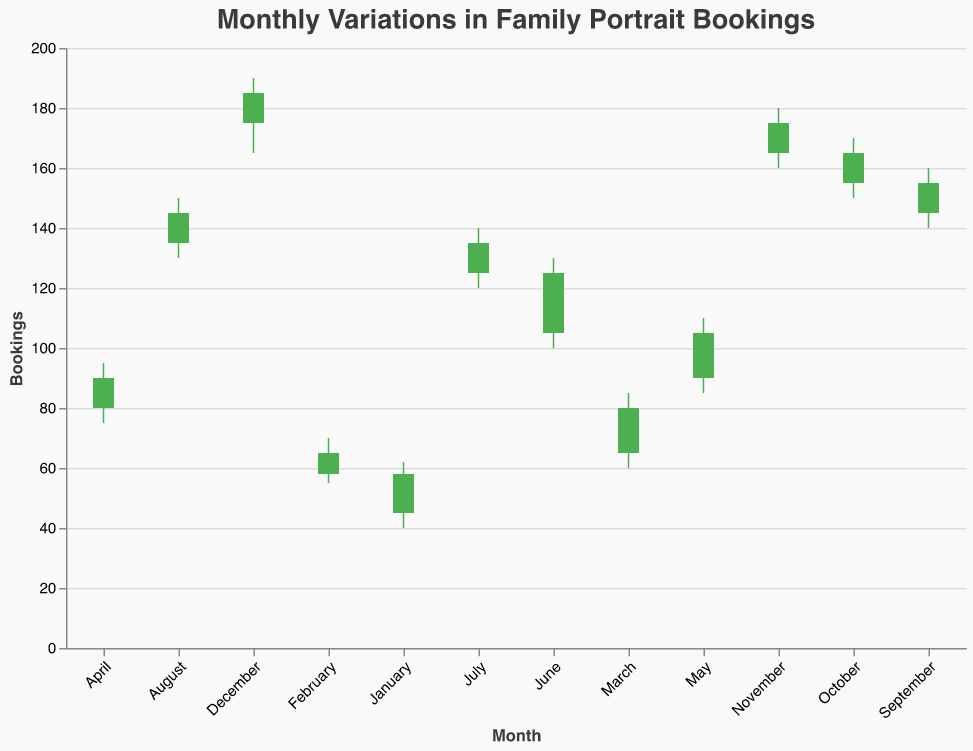what is the peak month for bookings? Based on the chart, the month with the highest bookings has the highest "High" value. The "High" value for December is 190, which is the highest compared to other months.
Answer: December which month shows the hardest drop from its opening to closing value? The month with the hardest drop will have the largest difference between the "Open" and "Close" values where the "Close" is less than the "Open". January shows a drop from 45 (Open) to 58 (Close) by 13 units.
Answer: January between June and August, which month had the highest range of bookings? The range of bookings for each month can be calculated by subtracting the "Low" value from the "High" value. For June, the range is 130 - 100 = 30. For July, the range is 140 - 120 = 20. And for August, the range is 150 - 130 = 20. Therefore, June had the highest range.
Answer: June which months experienced a rise in bookings from the start to the end of the month? A rise in bookings means the "Close" value is higher than the "Open" value. The months where this is true are: January (58>45), February (65>58), March (80>65), April (90>80), May (105>90), June (125>105), July (135>125), August (145>135), September (155>145), October (165>155), November (175>165), December (185>175).
Answer: January, February, March, April, May, June, July, August, September, October, November, December How does the average high booking value in the first half of the year compare to the second half? To find the average high values, sum up the high values for the months in each half and divide by 6. First half (January to June): (62 + 70 + 85 + 95 + 110 + 130) / 6 = 552 / 6 = 92. Second half (July to December): (140 + 150 + 160 + 170 + 180 + 190) / 6 = 990 / 6 = 165. Therefore, the average high value in the second half is higher.
Answer: Second half is higher what is the lowest booking value recorded throughout the year? The lowest booking value throughout the year is represented by the lowest "Low" value in the dataset. The lowest "Low" value recorded is 40 in January.
Answer: 40 Which month experienced the smallest range in bookings? To find the month with the smallest range, subtract the "Low" value from the "High" value for each month and find the smallest result. January: 62-40=22, February: 70-55=15, March: 85-60=25, April: 95-75=20, May: 110-85=25, June: 130-100=30, July: 140-120=20, August: 150-130=20, September: 160-140=20, October: 170-150=20, November: 180-160=20, December: 190-165=25. February has the smallest range of 15.
Answer: February what is the total increase in booking from January to December? The total increase in booking is calculated as the difference between the final "Close" value in December and the initial "Open" value in January. December's "Close" is 185 and January's "Open" is 45. Total increase = 185 - 45 = 140.
Answer: 140 